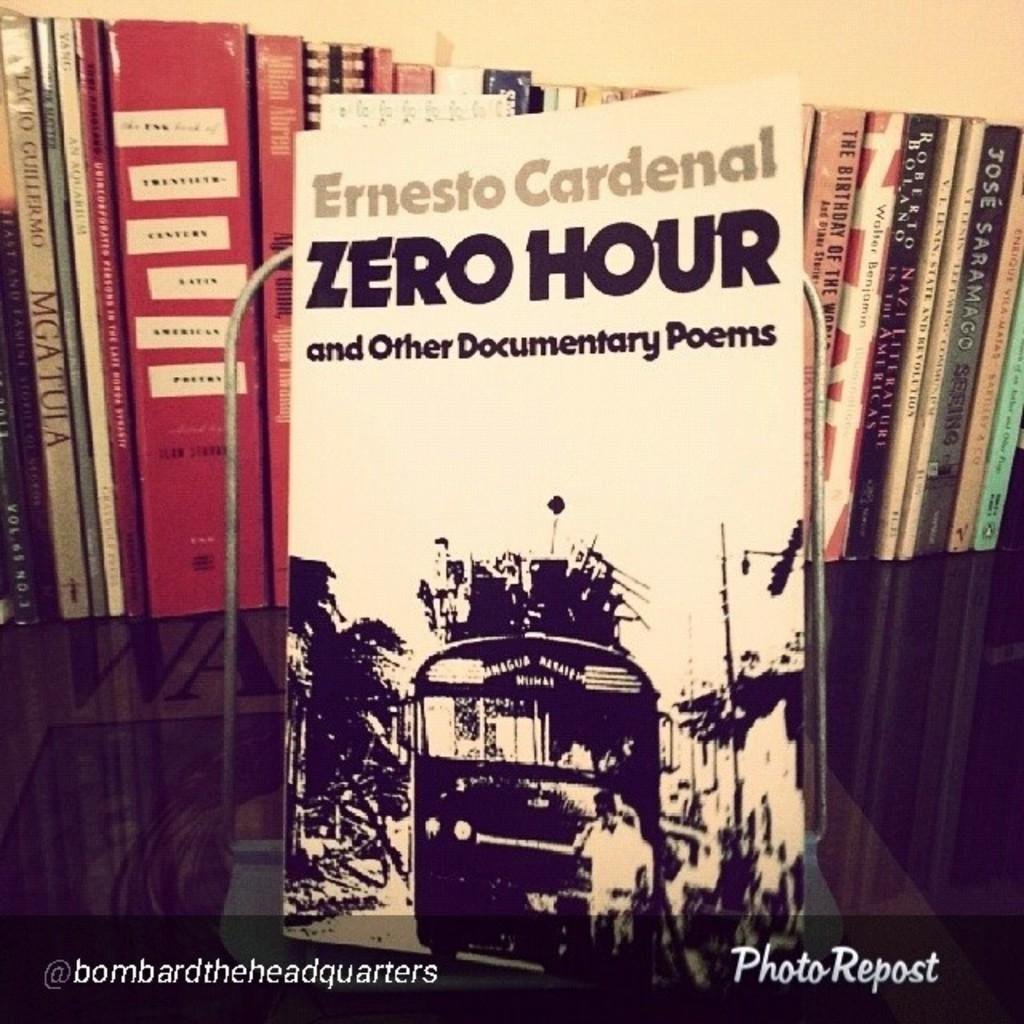<image>
Give a short and clear explanation of the subsequent image. A book by Ernesto Cardenal called Zero House sits on a shelf with other books 